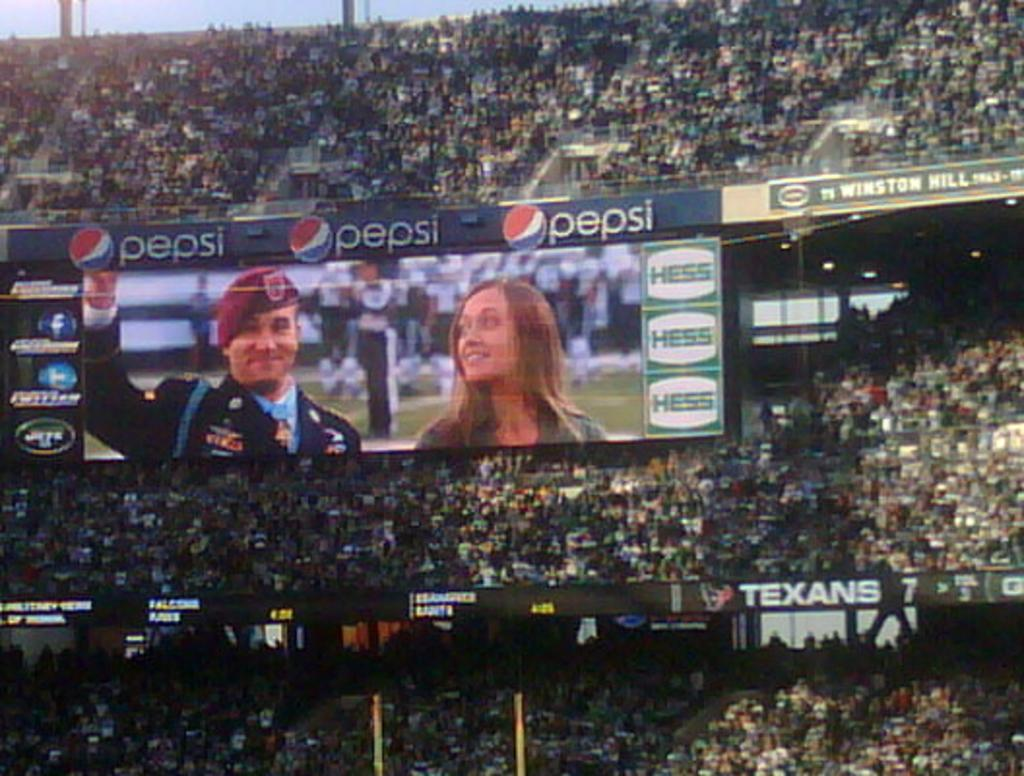<image>
Share a concise interpretation of the image provided. Two people are sown on a screen in an arena with a Pepsi advertisement above. 